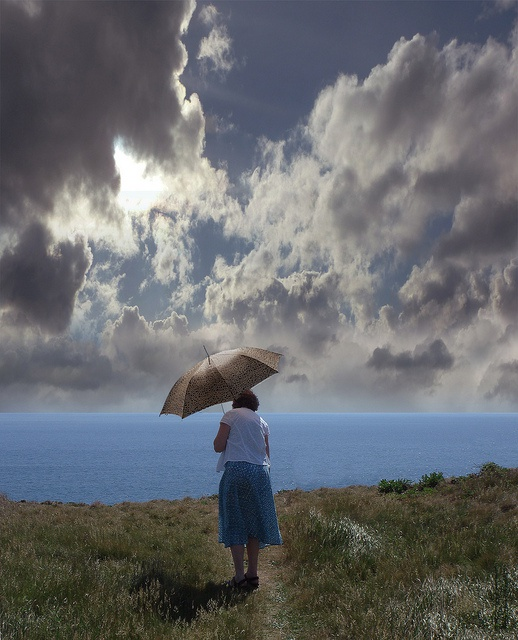Describe the objects in this image and their specific colors. I can see people in gray, black, and navy tones and umbrella in gray, black, and darkgray tones in this image. 